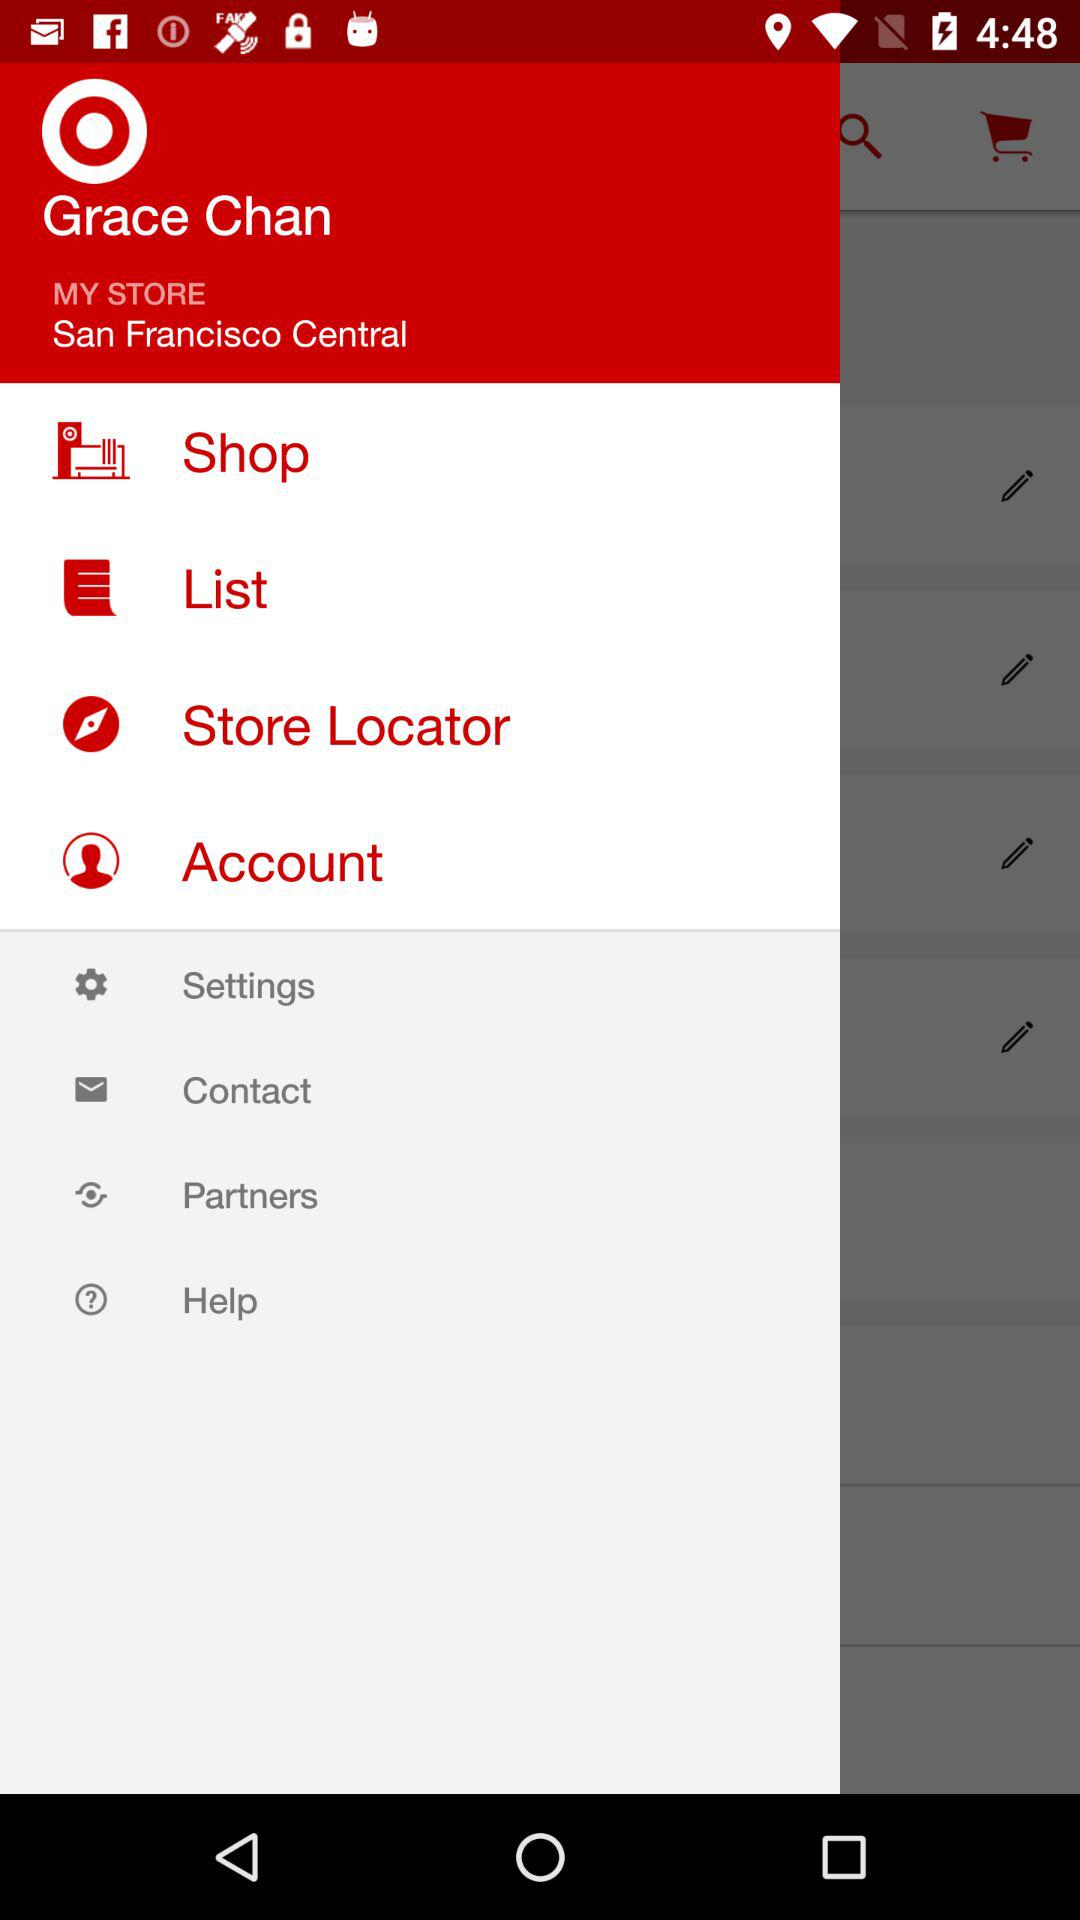What is the name of the user? The name of the user is Grace Chan. 